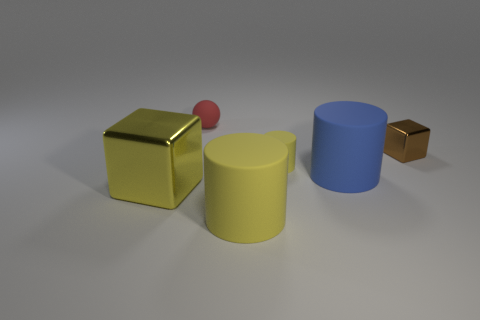Add 2 tiny brown shiny cubes. How many objects exist? 8 Subtract all big yellow matte cylinders. How many cylinders are left? 2 Subtract 1 balls. How many balls are left? 0 Subtract all large purple matte balls. Subtract all big metal cubes. How many objects are left? 5 Add 3 large yellow rubber cylinders. How many large yellow rubber cylinders are left? 4 Add 2 tiny rubber cylinders. How many tiny rubber cylinders exist? 3 Subtract all brown cubes. How many cubes are left? 1 Subtract 2 yellow cylinders. How many objects are left? 4 Subtract all blocks. How many objects are left? 4 Subtract all brown cubes. Subtract all cyan cylinders. How many cubes are left? 1 